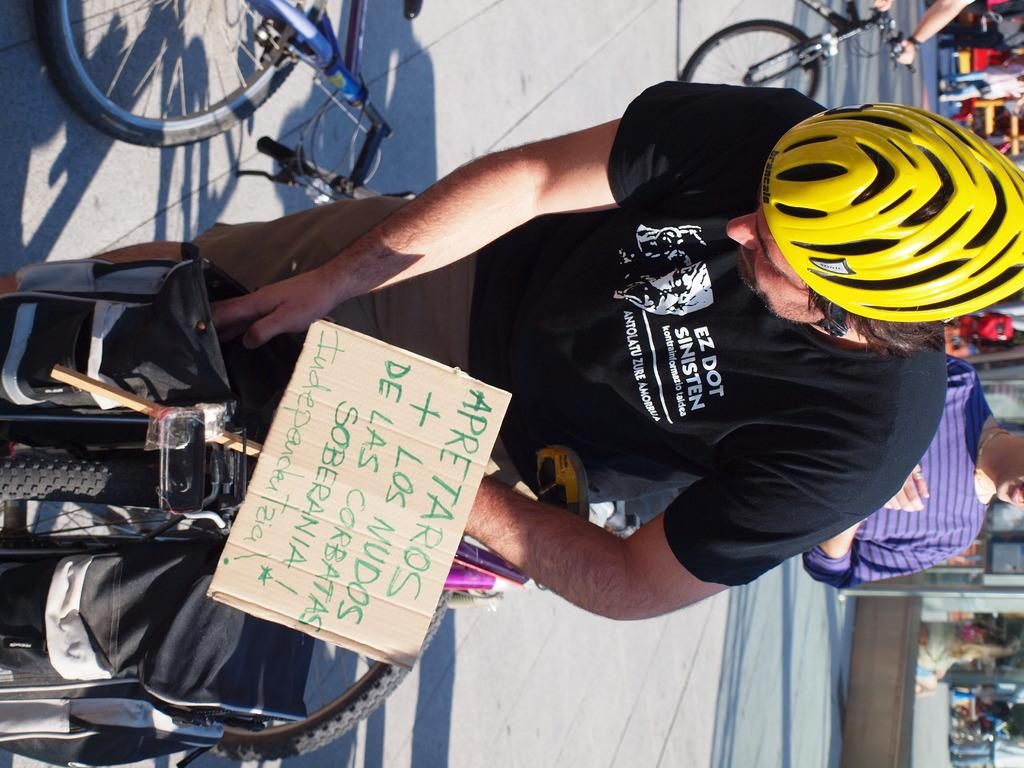<image>
Present a compact description of the photo's key features. Biker with a yellow helmet with a sign which says "Apretaros". 